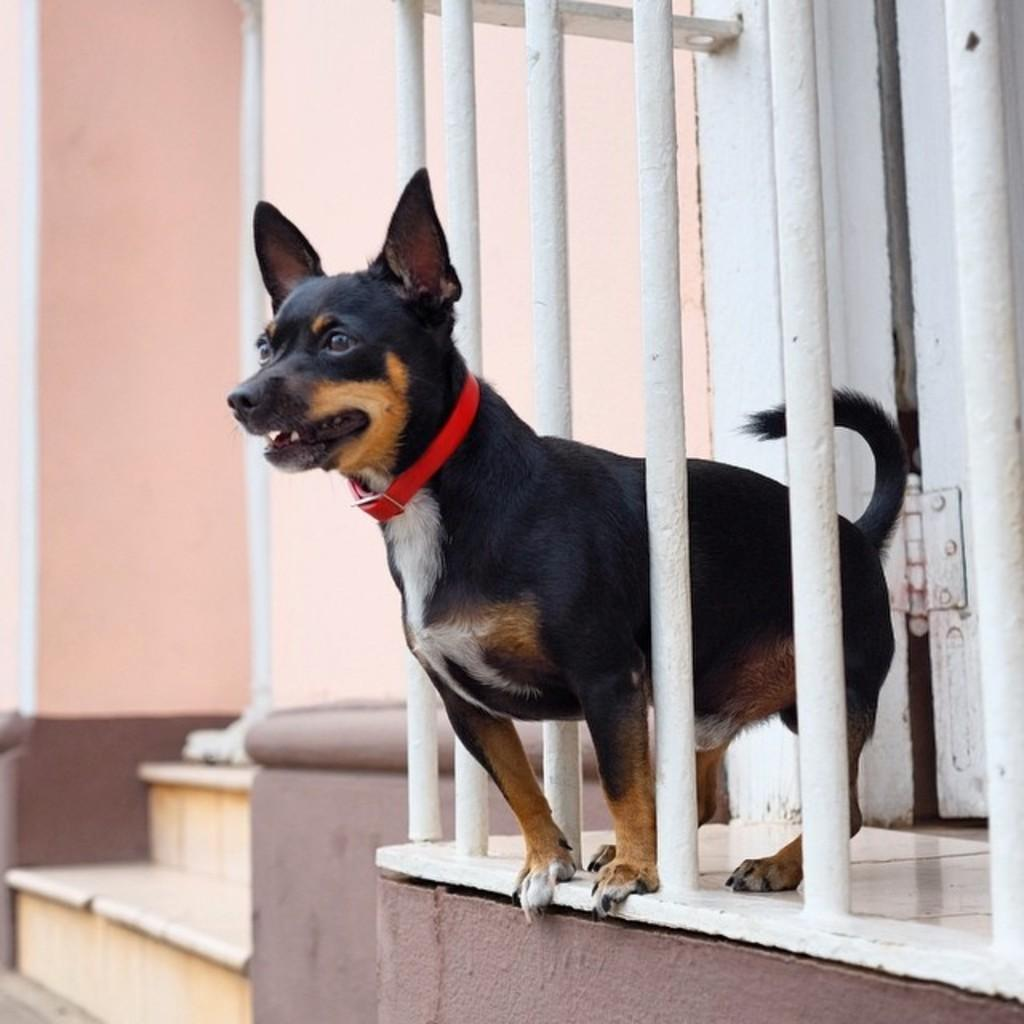What type of barrier can be seen in the image? There is a fence in the image. What animal is visible through the fence? A dog is visible through the fence. What architectural feature is located on the left side of the image? There is a staircase on the left side of the image. What structure is also present on the left side of the image? There is a wall on the left side of the image. How many members are on the team visible in the image? There is no team present in the image. What type of creature can be seen moving slowly on the ground in the image? There is no snail present in the image. 